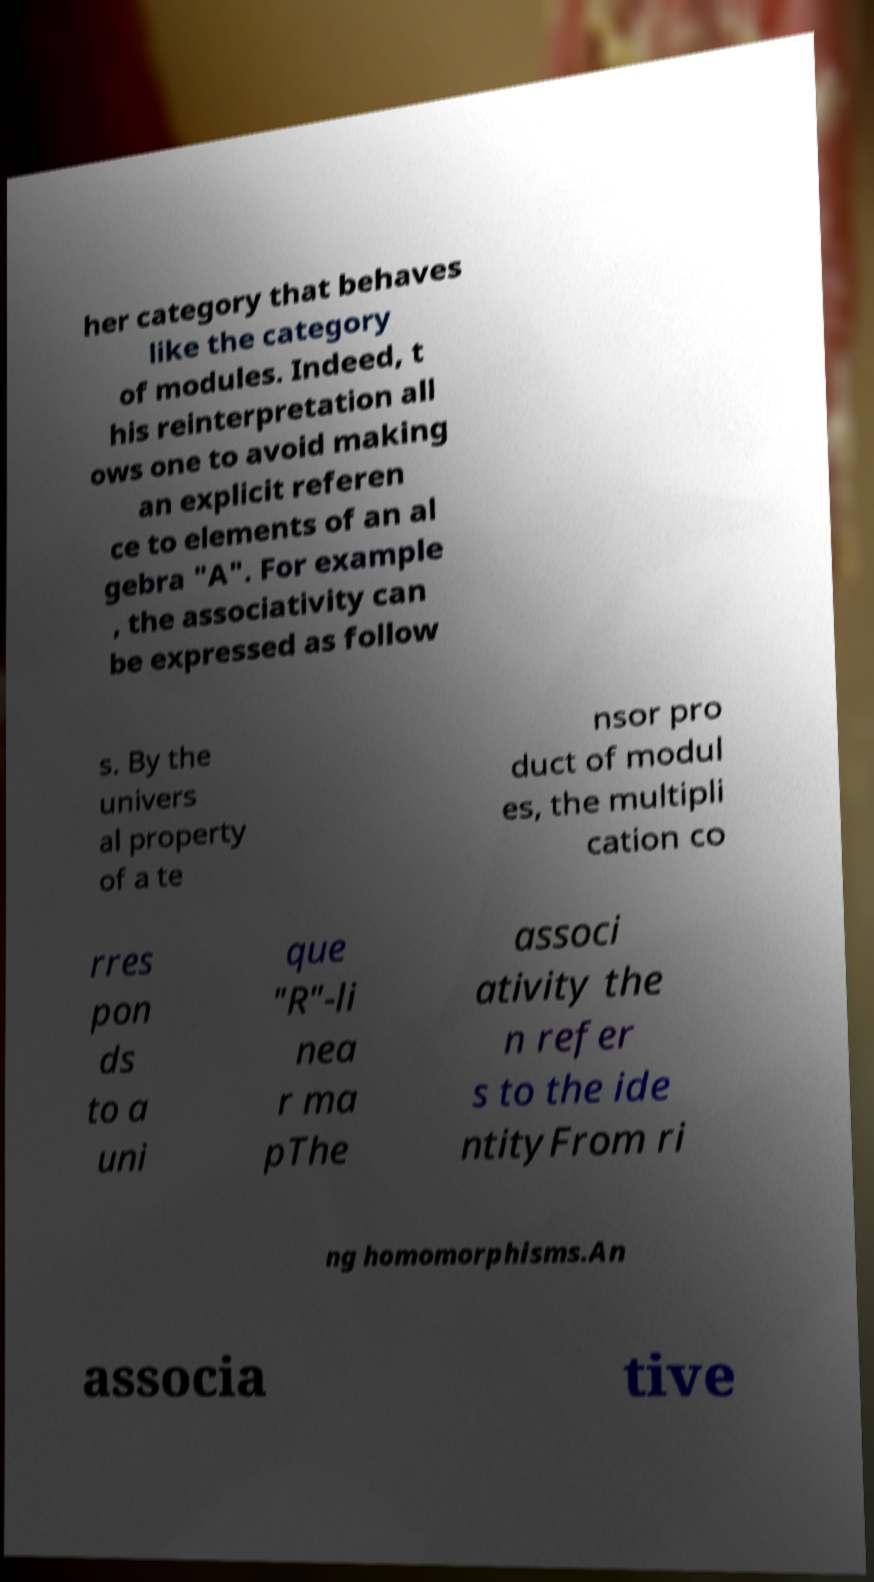Could you assist in decoding the text presented in this image and type it out clearly? her category that behaves like the category of modules. Indeed, t his reinterpretation all ows one to avoid making an explicit referen ce to elements of an al gebra "A". For example , the associativity can be expressed as follow s. By the univers al property of a te nsor pro duct of modul es, the multipli cation co rres pon ds to a uni que "R"-li nea r ma pThe associ ativity the n refer s to the ide ntityFrom ri ng homomorphisms.An associa tive 